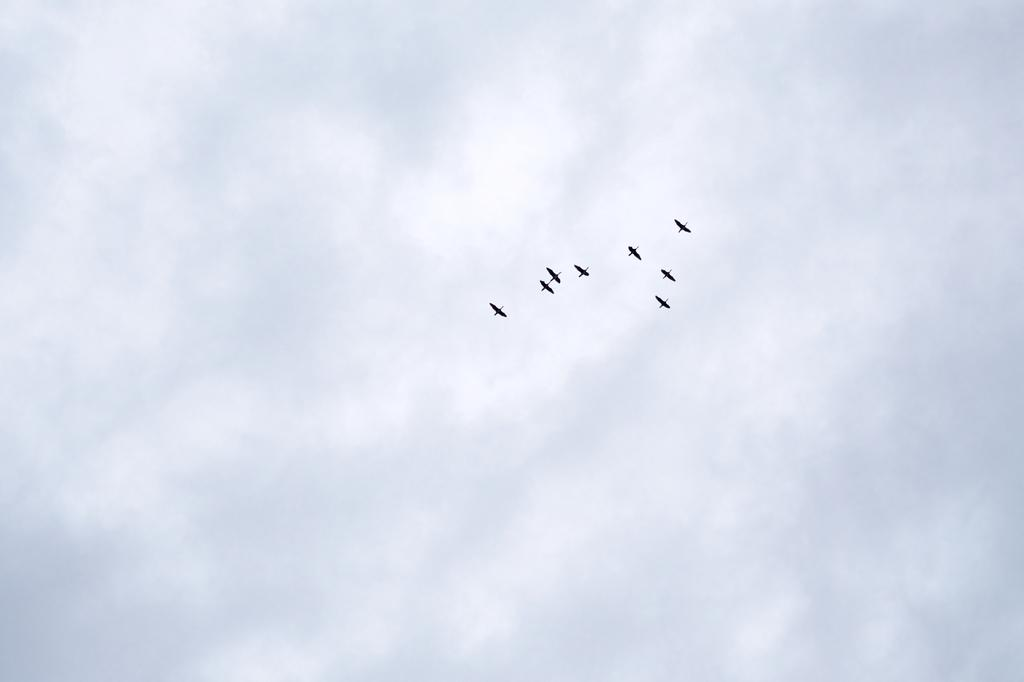What is happening in the image? There are birds flying in the image. What can be seen in the background of the image? The sky is visible in the background of the image. What is the condition of the sky in the image? Clouds are present in the sky. What type of leather is visible on the birds in the image? There is no leather present on the birds in the image; they are simply flying. How does the wind affect the birds in the image? The provided facts do not mention the wind, so we cannot determine its effect on the birds in the image. 